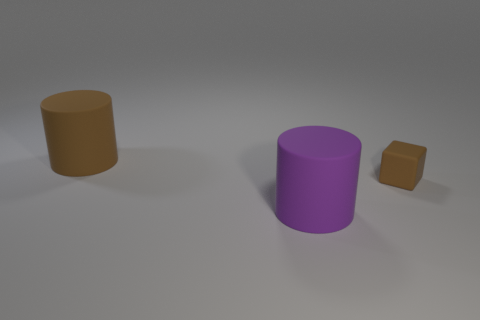What could possibly be the purpose of arranging these objects in this manner? The arrangement of the objects might be part of a visual composition exercise, a study in 3D modeling, or a test of rendering techniques. The varying sizes and distances could be used to practice perspective, or it could simply be a random placement with no particular intention beyond creating a visually interesting scene. 